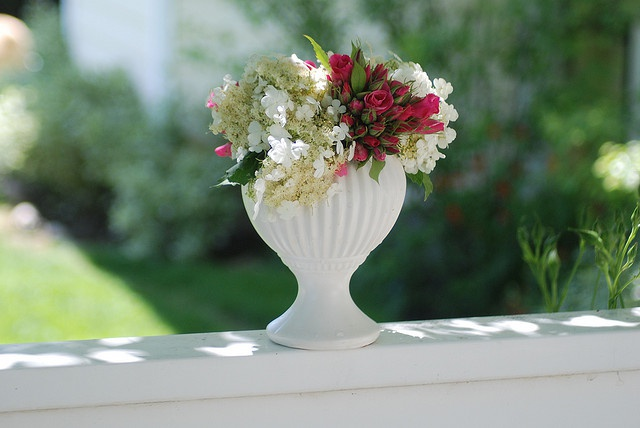Describe the objects in this image and their specific colors. I can see potted plant in black, darkgray, lightgray, and olive tones and vase in black, darkgray, and lightgray tones in this image. 